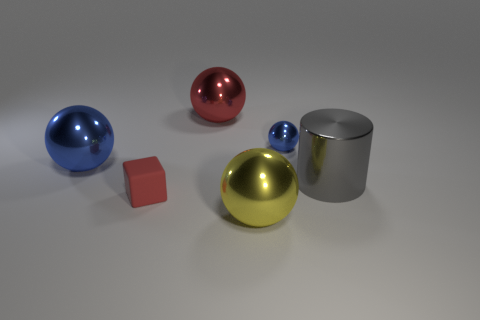Assuming these objects are on a surface, can you tell me if it appears level or slanted? The surface upon which these objects rest appears level. There's no visible distortion or alignment on the objects that would suggest a slope. Shadows are consistent and objects are stable, further indicating a flat surface. 